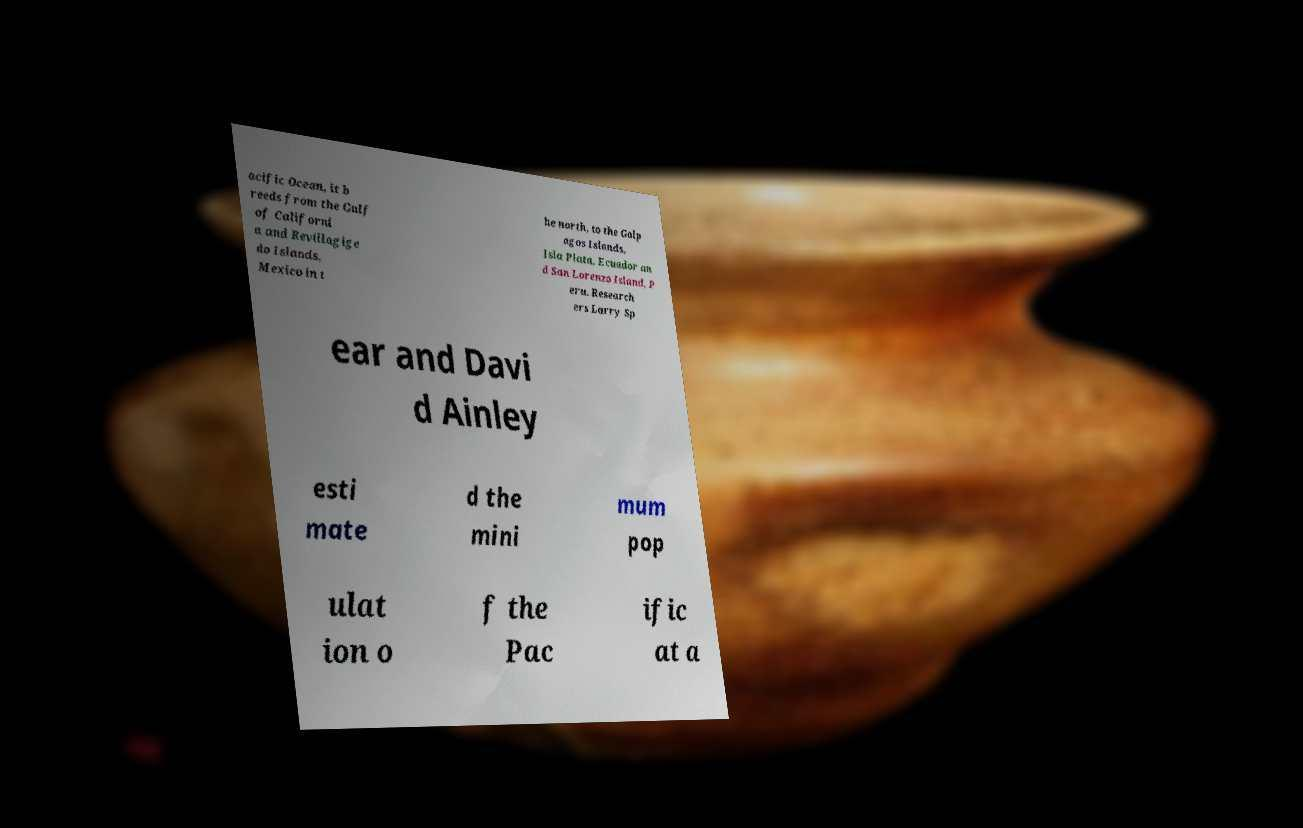I need the written content from this picture converted into text. Can you do that? acific Ocean, it b reeds from the Gulf of Californi a and Revillagige do Islands, Mexico in t he north, to the Galp agos Islands, Isla Plata, Ecuador an d San Lorenzo Island, P eru. Research ers Larry Sp ear and Davi d Ainley esti mate d the mini mum pop ulat ion o f the Pac ific at a 